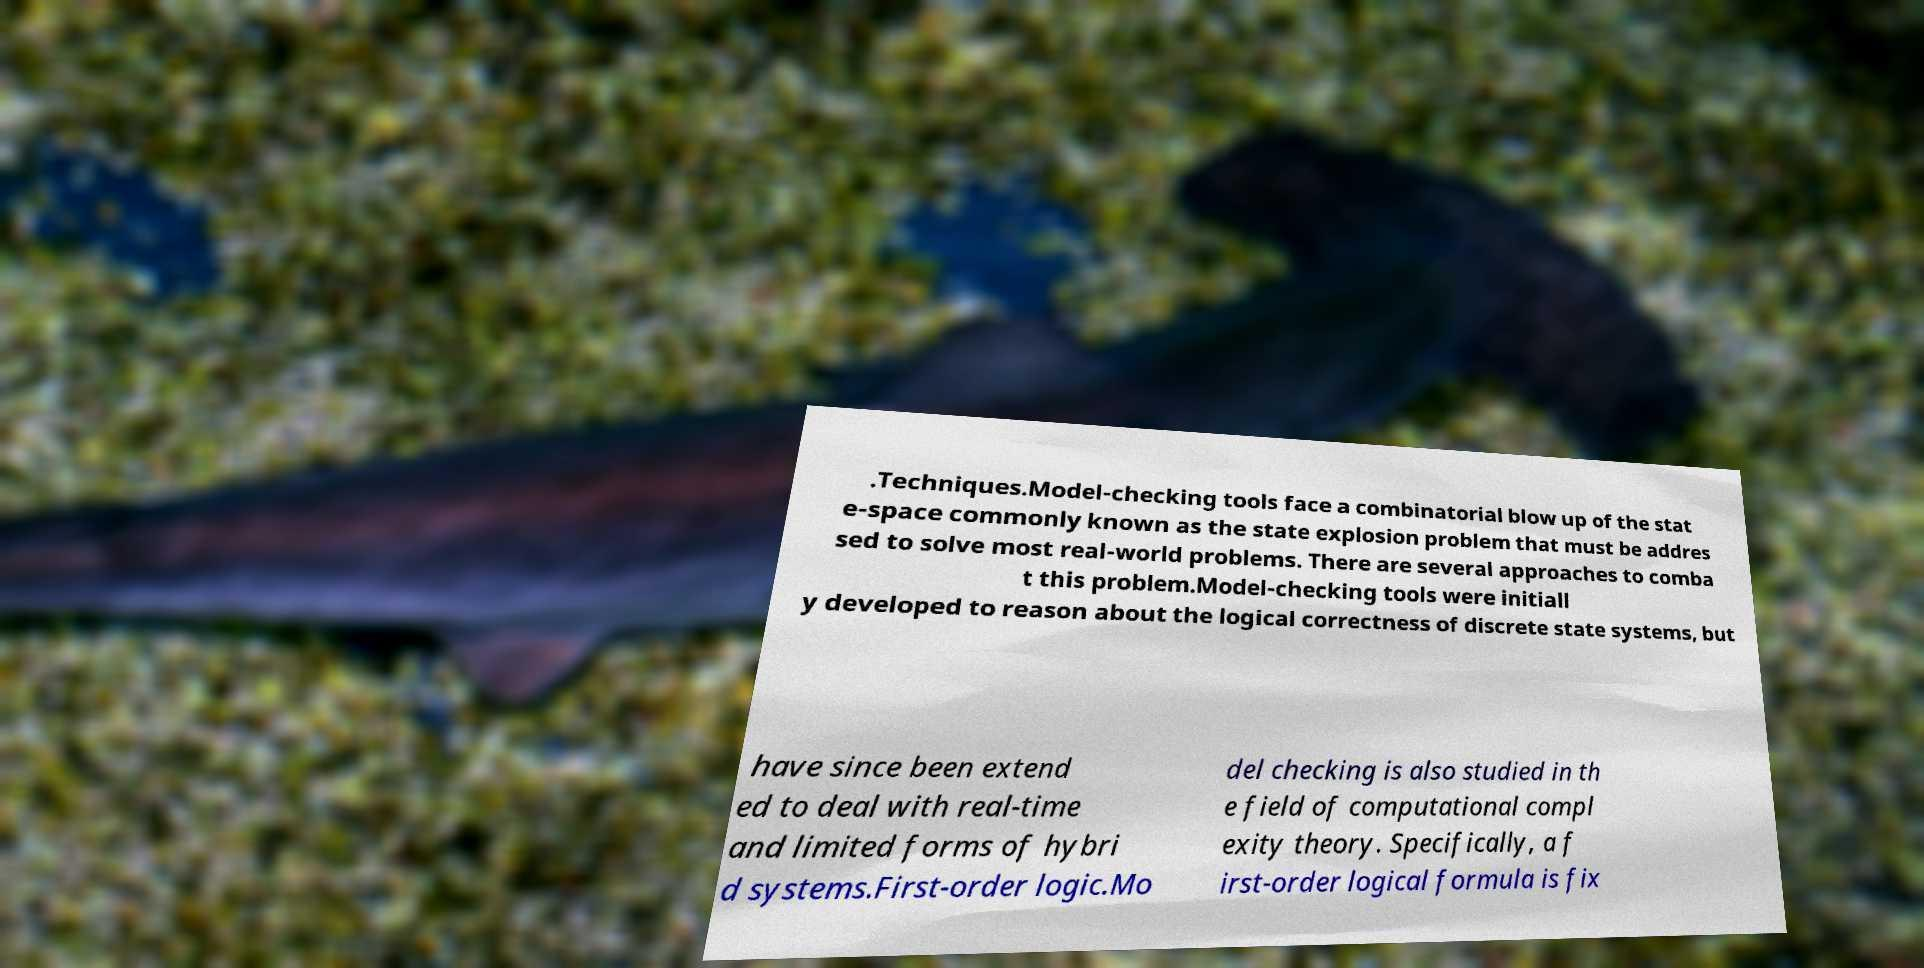Can you read and provide the text displayed in the image?This photo seems to have some interesting text. Can you extract and type it out for me? .Techniques.Model-checking tools face a combinatorial blow up of the stat e-space commonly known as the state explosion problem that must be addres sed to solve most real-world problems. There are several approaches to comba t this problem.Model-checking tools were initiall y developed to reason about the logical correctness of discrete state systems, but have since been extend ed to deal with real-time and limited forms of hybri d systems.First-order logic.Mo del checking is also studied in th e field of computational compl exity theory. Specifically, a f irst-order logical formula is fix 